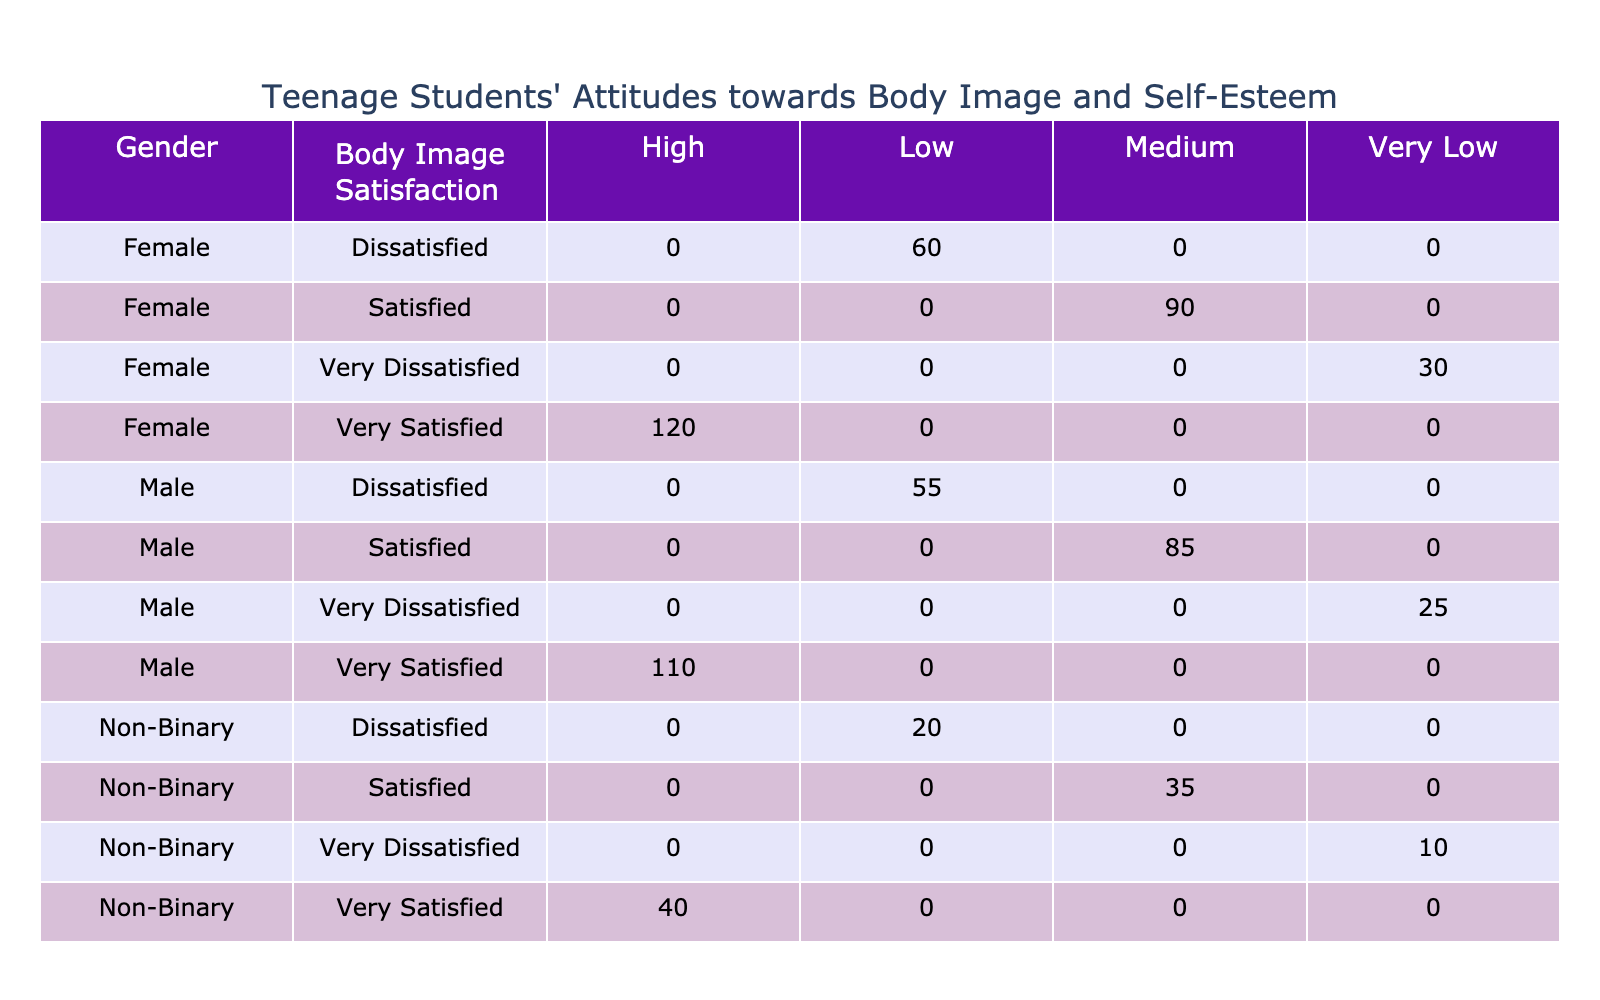What is the total number of students who are very satisfied with their body image? To find this, we look at the table for the "Very Satisfied" row under each gender and add the respective values: 120 (Female) + 110 (Male) + 40 (Non-Binary) = 270.
Answer: 270 Which gender has the lowest number of students in the 'Very Dissatisfied' category? We will compare the 'Very Dissatisfied' values for each gender: 30 (Female), 25 (Male), 10 (Non-Binary). The lowest value is 10 for Non-Binary.
Answer: Non-Binary How many more males feel 'Dissatisfied' compared to females? The number of dissatisfied males is 55, and females is 60. The difference is calculated as 60 - 55 = 5.
Answer: 5 What percentage of female students reported a high self-esteem level? The number of female students with high self-esteem is 120, out of a total of 300 female students (120 + 90 + 60 + 30). The percentage is calculated as (120/300) * 100 = 40%.
Answer: 40% Is it true that all genders have a 'Very Satisfied' category? Checking the table, we see that there are entries for 'Very Satisfied' for Female, Male, and Non-Binary. Thus, the statement is true.
Answer: Yes What is the total number of students with medium self-esteem across all body image satisfaction levels? We need to sum the number of students with 'Medium' self-esteem from each gender: 90 (Female) + 85 (Male) + 35 (Non-Binary) = 210.
Answer: 210 In terms of body image satisfaction, which gender has the highest number of students in either the satisfied or very satisfied categories? For satisfaction: Female = 90 + 120 = 210, Male = 85 + 110 = 195, Non-Binary = 35 + 40 = 75. The highest total is 210 for Females.
Answer: Female What is the total number of students in the 'Low' self-esteem category? We sum the 'Low' self-esteem values for each gender: 60 (Female) + 55 (Male) + 20 (Non-Binary) = 135.
Answer: 135 Are there more students dissatisfied with body image than those very dissatisfied across all genders? Total 'Dissatisfied' students: 60 (Female) + 55 (Male) + 20 (Non-Binary) = 135. Total 'Very Dissatisfied': 30 (Female) + 25 (Male) + 10 (Non-Binary) = 65. Since 135 > 65, the statement is true.
Answer: Yes 